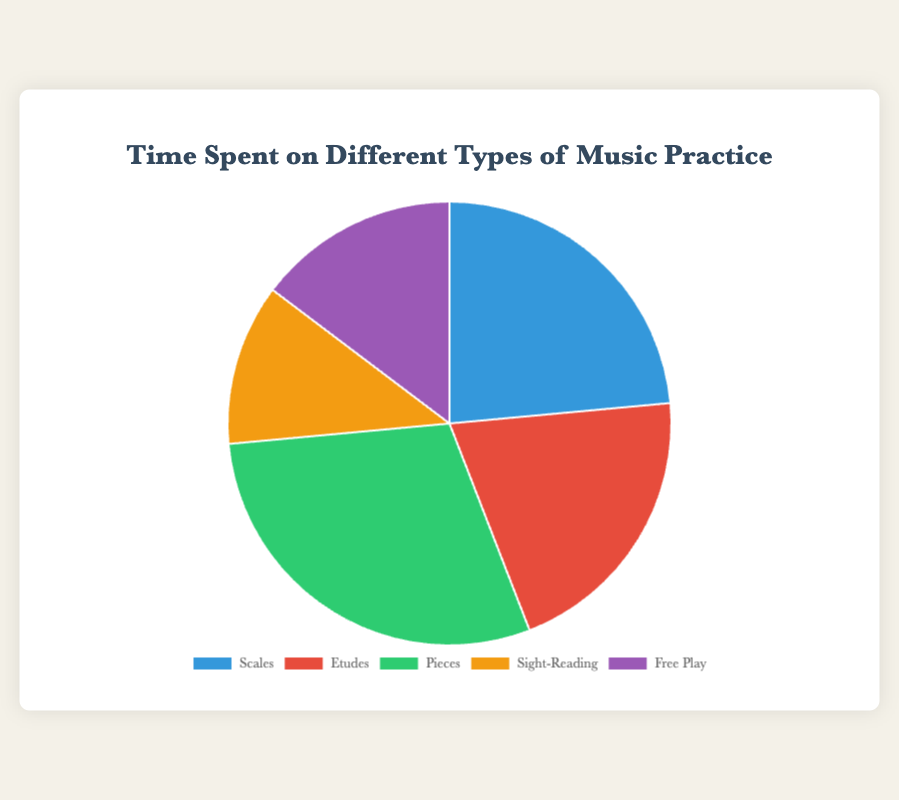what is the total number of hours spent on practice per week? To find the total number of hours, sum all the hours: Scales (4) + Etudes (3.5) + Pieces (5) + Sight-Reading (2) + Free Play (2.5). The total is 4 + 3.5 + 5 + 2 + 2.5 = 17 hours
Answer: 17 which type of practice has the highest amount of time spent? Look at the pie chart to find the section with the largest area. Pieces has the largest section, indicating it has the highest amount of time spent
Answer: Pieces what is the difference in hours between time spent on Pieces and time spent on Scales? Pieces (5 hours) minus Scales (4 hours). The difference is 5 - 4 = 1 hour
Answer: 1 hour which type of practice is represented by the green section? Identify the green section in the pie chart. According to the code, it corresponds to "Pieces"
Answer: Pieces are there more hours spent on Scales or Sight-Reading? Compare the hours spent on Scales (4 hours) to Sight-Reading (2 hours). 4 hours is greater than 2 hours
Answer: Scales what percentage of the total practice time is spent on Etudes? Calculate the percentage: (time spent on Etudes / total practice time) * 100. Etudes: 3.5 hours, Total: 17 hours. Percentage = (3.5 / 17) * 100 ≈ 20.6%
Answer: about 20.6% which two types of practice combined have the same total time as Pieces? Pieces is 5 hours. Check combinations: Scales + Sight-Reading = 4 + 2 = 6 (no), Etudes + Free Play = 3.5 + 2.5 = 6 (no), Scales + Free Play = 4 + 2.5 = 6.5 (no), Etudes + Sight-Reading = 3.5 + 2 = 5.5 (no), Free Play + Sight-Reading = 2.5 + 2 = 4.5 (no). No exact match. However, Etudes + Sight-Reading (3.5 + 2) + Free Play (2.5) exceeds it slightly
Answer: No exact match, closest is Etudes and Sight-Reading what is the average time spent per type of practice? Sum all hours and divide by the number of practice types: (4 + 3.5 + 5 + 2 + 2.5) / 5. The sum is 17, divided by 5 = 3.4 hours
Answer: 3.4 hours how much more time is spent on Pieces compared to the total time spent on Sight-Reading and Free Play combined? Total time spent on Sight-Reading and Free Play: 2 + 2.5 = 4.5 hours. Time spent on Pieces = 5 hours. Difference: 5 - 4.5 = 0.5 hours
Answer: 0.5 hours which practice type and time duration combination corresponds to the red section of the pie chart? Check the color-coded sections: the red section represents Etudes, which is 3.5 hours
Answer: Etudes, 3.5 hours 